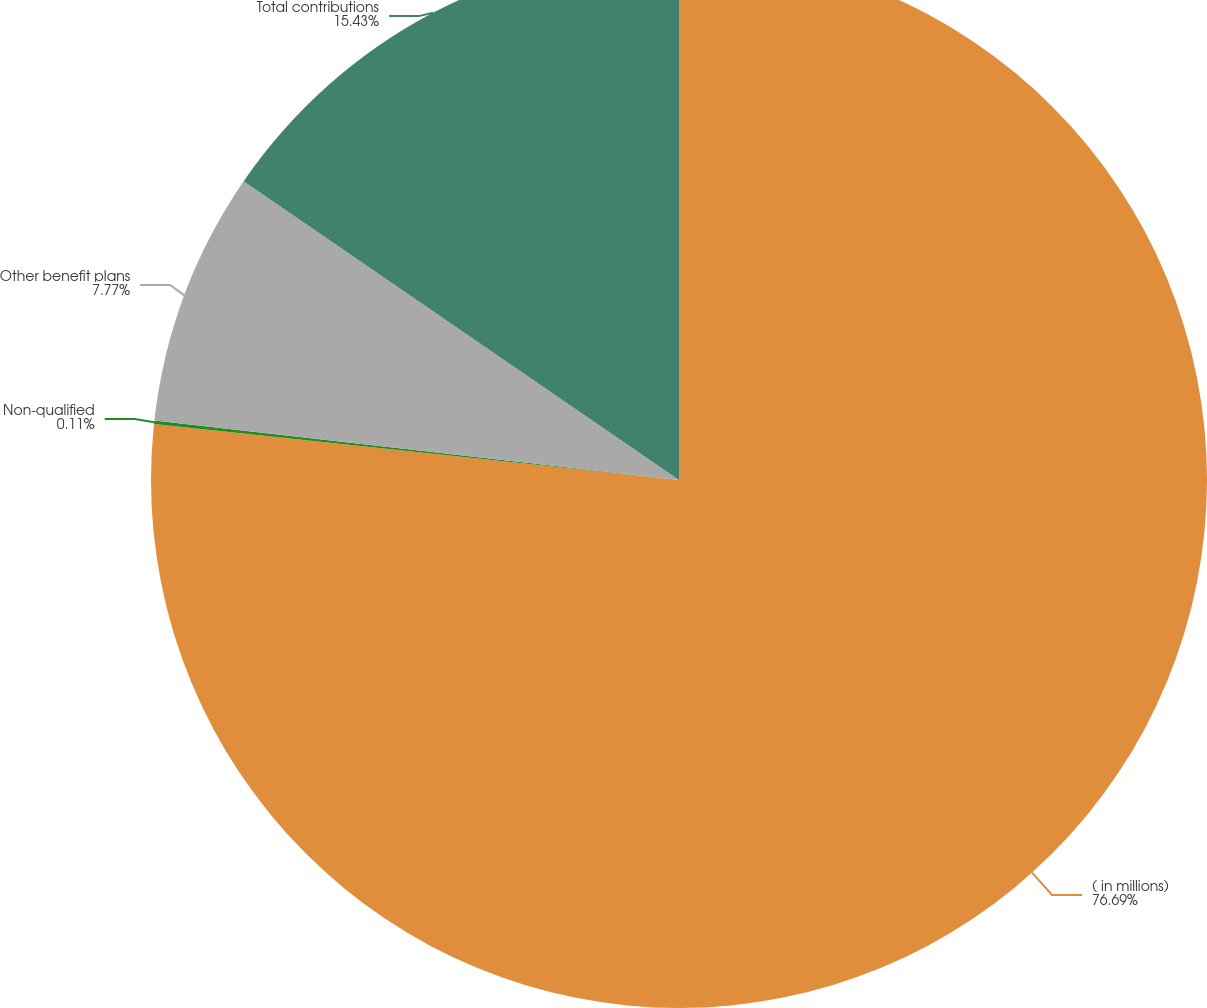Convert chart. <chart><loc_0><loc_0><loc_500><loc_500><pie_chart><fcel>( in millions)<fcel>Non-qualified<fcel>Other benefit plans<fcel>Total contributions<nl><fcel>76.69%<fcel>0.11%<fcel>7.77%<fcel>15.43%<nl></chart> 